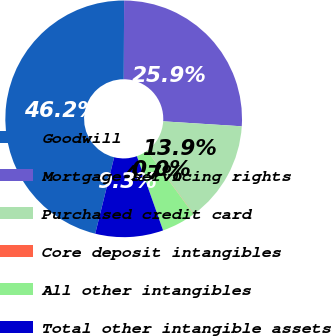Convert chart. <chart><loc_0><loc_0><loc_500><loc_500><pie_chart><fcel>Goodwill<fcel>Mortgage servicing rights<fcel>Purchased credit card<fcel>Core deposit intangibles<fcel>All other intangibles<fcel>Total other intangible assets<nl><fcel>46.19%<fcel>25.95%<fcel>13.89%<fcel>0.04%<fcel>4.66%<fcel>9.27%<nl></chart> 